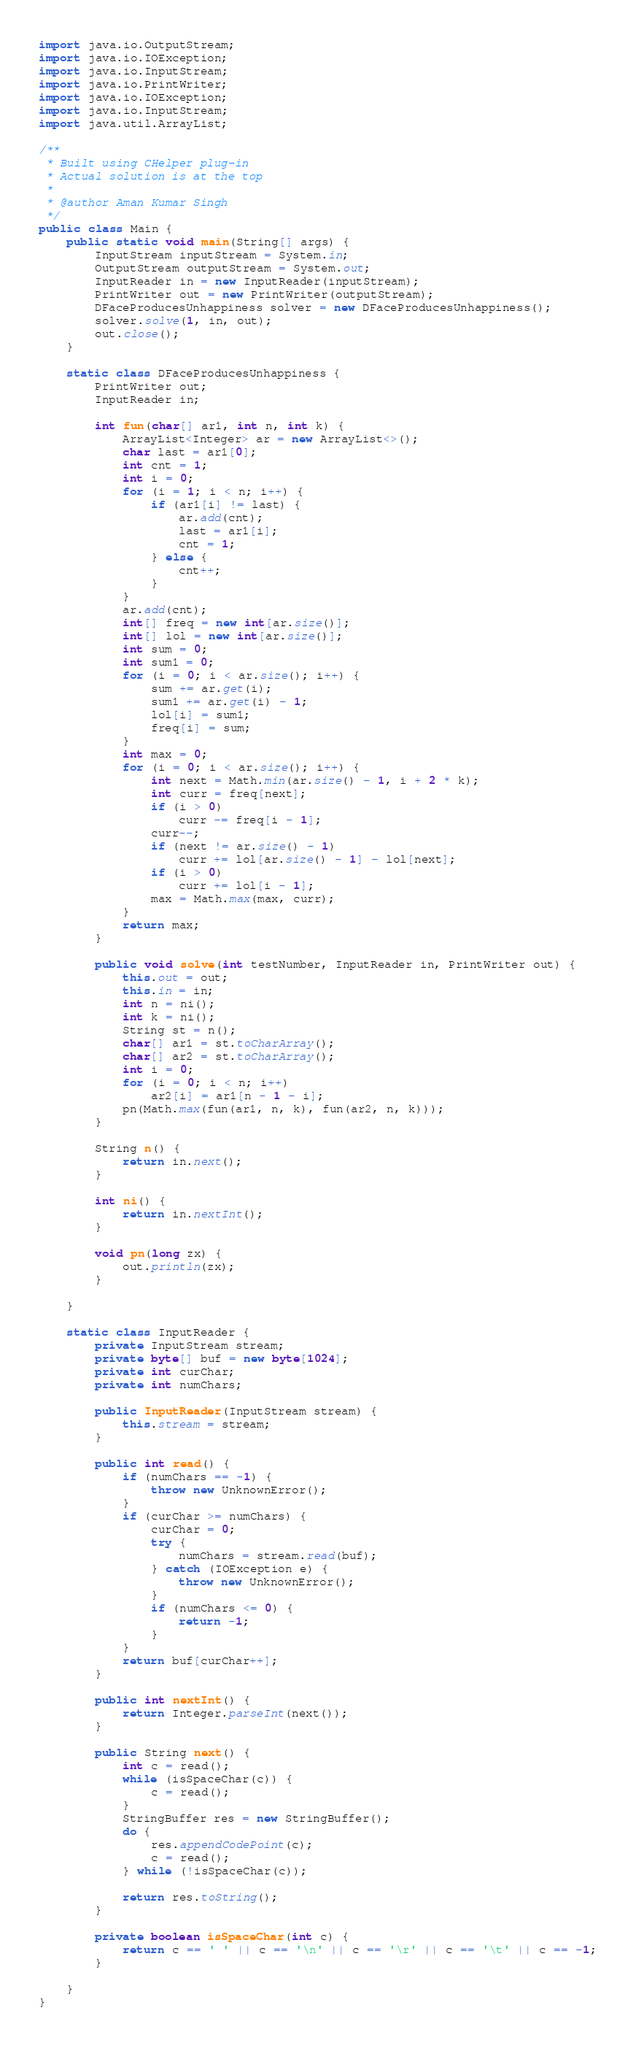<code> <loc_0><loc_0><loc_500><loc_500><_Java_>import java.io.OutputStream;
import java.io.IOException;
import java.io.InputStream;
import java.io.PrintWriter;
import java.io.IOException;
import java.io.InputStream;
import java.util.ArrayList;

/**
 * Built using CHelper plug-in
 * Actual solution is at the top
 *
 * @author Aman Kumar Singh
 */
public class Main {
    public static void main(String[] args) {
        InputStream inputStream = System.in;
        OutputStream outputStream = System.out;
        InputReader in = new InputReader(inputStream);
        PrintWriter out = new PrintWriter(outputStream);
        DFaceProducesUnhappiness solver = new DFaceProducesUnhappiness();
        solver.solve(1, in, out);
        out.close();
    }

    static class DFaceProducesUnhappiness {
        PrintWriter out;
        InputReader in;

        int fun(char[] ar1, int n, int k) {
            ArrayList<Integer> ar = new ArrayList<>();
            char last = ar1[0];
            int cnt = 1;
            int i = 0;
            for (i = 1; i < n; i++) {
                if (ar1[i] != last) {
                    ar.add(cnt);
                    last = ar1[i];
                    cnt = 1;
                } else {
                    cnt++;
                }
            }
            ar.add(cnt);
            int[] freq = new int[ar.size()];
            int[] lol = new int[ar.size()];
            int sum = 0;
            int sum1 = 0;
            for (i = 0; i < ar.size(); i++) {
                sum += ar.get(i);
                sum1 += ar.get(i) - 1;
                lol[i] = sum1;
                freq[i] = sum;
            }
            int max = 0;
            for (i = 0; i < ar.size(); i++) {
                int next = Math.min(ar.size() - 1, i + 2 * k);
                int curr = freq[next];
                if (i > 0)
                    curr -= freq[i - 1];
                curr--;
                if (next != ar.size() - 1)
                    curr += lol[ar.size() - 1] - lol[next];
                if (i > 0)
                    curr += lol[i - 1];
                max = Math.max(max, curr);
            }
            return max;
        }

        public void solve(int testNumber, InputReader in, PrintWriter out) {
            this.out = out;
            this.in = in;
            int n = ni();
            int k = ni();
            String st = n();
            char[] ar1 = st.toCharArray();
            char[] ar2 = st.toCharArray();
            int i = 0;
            for (i = 0; i < n; i++)
                ar2[i] = ar1[n - 1 - i];
            pn(Math.max(fun(ar1, n, k), fun(ar2, n, k)));
        }

        String n() {
            return in.next();
        }

        int ni() {
            return in.nextInt();
        }

        void pn(long zx) {
            out.println(zx);
        }

    }

    static class InputReader {
        private InputStream stream;
        private byte[] buf = new byte[1024];
        private int curChar;
        private int numChars;

        public InputReader(InputStream stream) {
            this.stream = stream;
        }

        public int read() {
            if (numChars == -1) {
                throw new UnknownError();
            }
            if (curChar >= numChars) {
                curChar = 0;
                try {
                    numChars = stream.read(buf);
                } catch (IOException e) {
                    throw new UnknownError();
                }
                if (numChars <= 0) {
                    return -1;
                }
            }
            return buf[curChar++];
        }

        public int nextInt() {
            return Integer.parseInt(next());
        }

        public String next() {
            int c = read();
            while (isSpaceChar(c)) {
                c = read();
            }
            StringBuffer res = new StringBuffer();
            do {
                res.appendCodePoint(c);
                c = read();
            } while (!isSpaceChar(c));

            return res.toString();
        }

        private boolean isSpaceChar(int c) {
            return c == ' ' || c == '\n' || c == '\r' || c == '\t' || c == -1;
        }

    }
}

</code> 